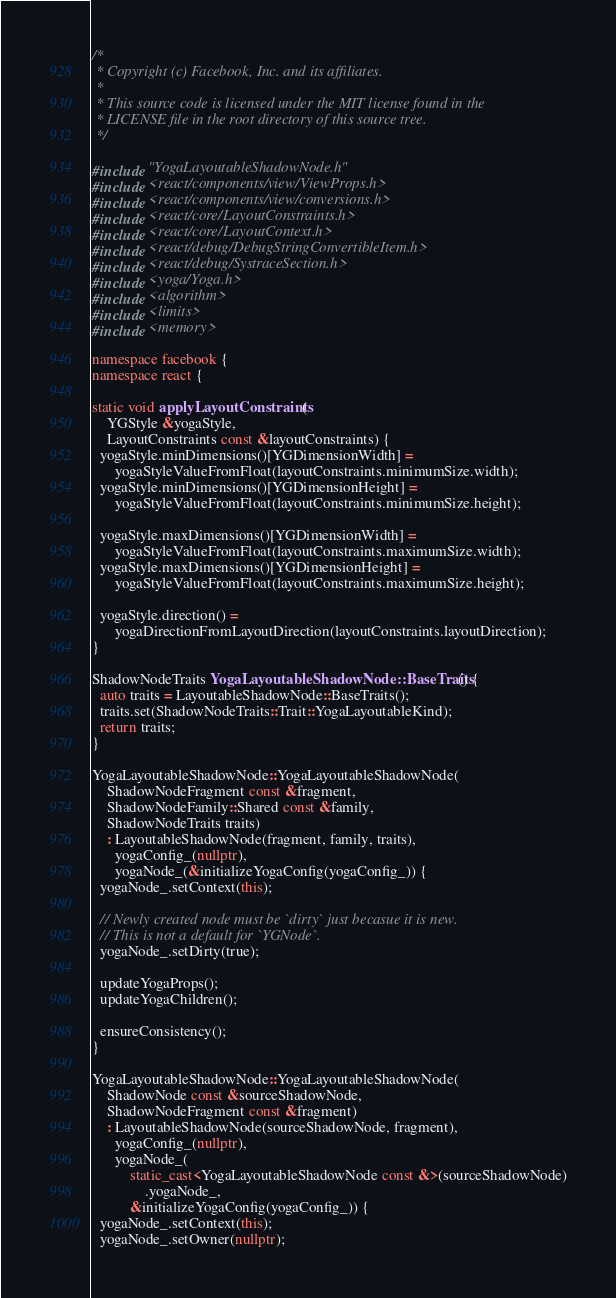Convert code to text. <code><loc_0><loc_0><loc_500><loc_500><_C++_>/*
 * Copyright (c) Facebook, Inc. and its affiliates.
 *
 * This source code is licensed under the MIT license found in the
 * LICENSE file in the root directory of this source tree.
 */

#include "YogaLayoutableShadowNode.h"
#include <react/components/view/ViewProps.h>
#include <react/components/view/conversions.h>
#include <react/core/LayoutConstraints.h>
#include <react/core/LayoutContext.h>
#include <react/debug/DebugStringConvertibleItem.h>
#include <react/debug/SystraceSection.h>
#include <yoga/Yoga.h>
#include <algorithm>
#include <limits>
#include <memory>

namespace facebook {
namespace react {

static void applyLayoutConstraints(
    YGStyle &yogaStyle,
    LayoutConstraints const &layoutConstraints) {
  yogaStyle.minDimensions()[YGDimensionWidth] =
      yogaStyleValueFromFloat(layoutConstraints.minimumSize.width);
  yogaStyle.minDimensions()[YGDimensionHeight] =
      yogaStyleValueFromFloat(layoutConstraints.minimumSize.height);

  yogaStyle.maxDimensions()[YGDimensionWidth] =
      yogaStyleValueFromFloat(layoutConstraints.maximumSize.width);
  yogaStyle.maxDimensions()[YGDimensionHeight] =
      yogaStyleValueFromFloat(layoutConstraints.maximumSize.height);

  yogaStyle.direction() =
      yogaDirectionFromLayoutDirection(layoutConstraints.layoutDirection);
}

ShadowNodeTraits YogaLayoutableShadowNode::BaseTraits() {
  auto traits = LayoutableShadowNode::BaseTraits();
  traits.set(ShadowNodeTraits::Trait::YogaLayoutableKind);
  return traits;
}

YogaLayoutableShadowNode::YogaLayoutableShadowNode(
    ShadowNodeFragment const &fragment,
    ShadowNodeFamily::Shared const &family,
    ShadowNodeTraits traits)
    : LayoutableShadowNode(fragment, family, traits),
      yogaConfig_(nullptr),
      yogaNode_(&initializeYogaConfig(yogaConfig_)) {
  yogaNode_.setContext(this);

  // Newly created node must be `dirty` just becasue it is new.
  // This is not a default for `YGNode`.
  yogaNode_.setDirty(true);

  updateYogaProps();
  updateYogaChildren();

  ensureConsistency();
}

YogaLayoutableShadowNode::YogaLayoutableShadowNode(
    ShadowNode const &sourceShadowNode,
    ShadowNodeFragment const &fragment)
    : LayoutableShadowNode(sourceShadowNode, fragment),
      yogaConfig_(nullptr),
      yogaNode_(
          static_cast<YogaLayoutableShadowNode const &>(sourceShadowNode)
              .yogaNode_,
          &initializeYogaConfig(yogaConfig_)) {
  yogaNode_.setContext(this);
  yogaNode_.setOwner(nullptr);</code> 